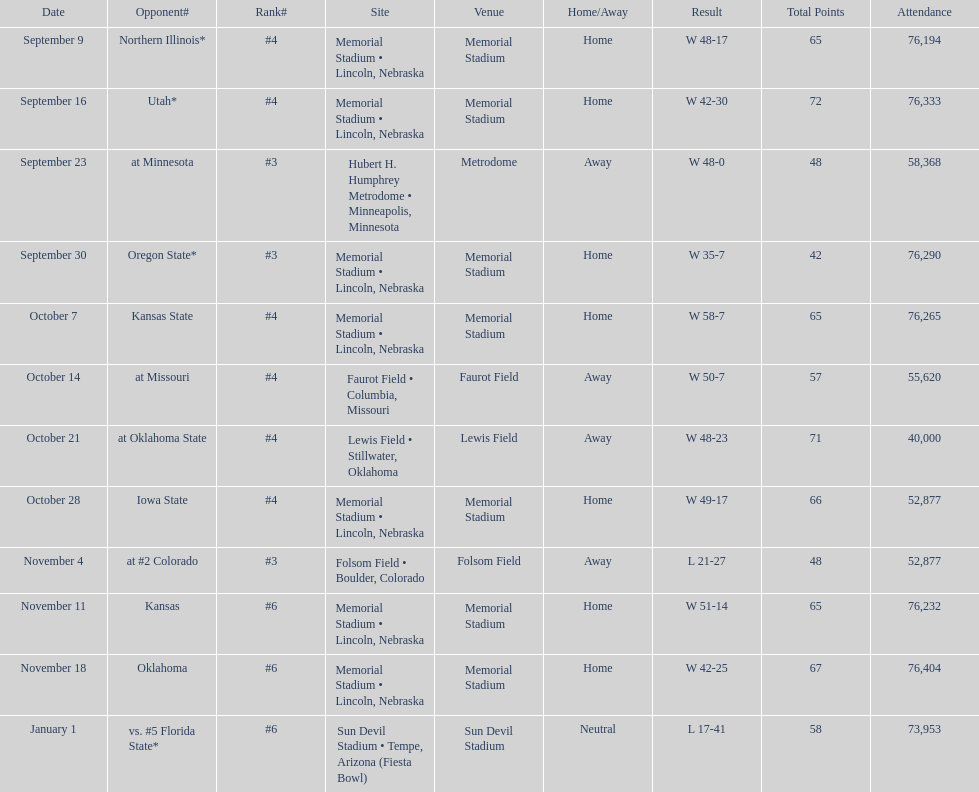Which month is listed the least on this chart? January. 